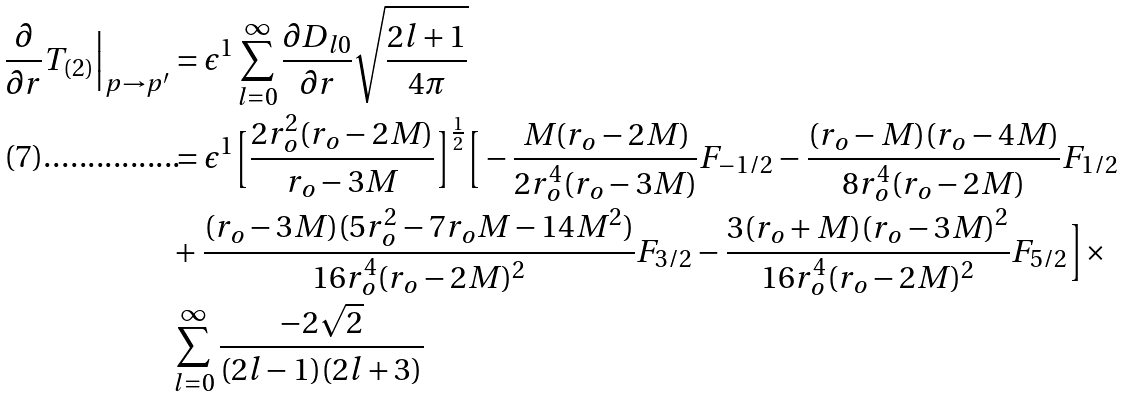Convert formula to latex. <formula><loc_0><loc_0><loc_500><loc_500>\frac { \partial } { \partial r } T _ { ( 2 ) } \Big | _ { p \to p ^ { \prime } } & = \epsilon ^ { 1 } \sum _ { l = 0 } ^ { \infty } \frac { \partial D _ { l 0 } } { \partial r } \sqrt { \frac { 2 l + 1 } { 4 \pi } } \\ & = \epsilon ^ { 1 } \Big [ \frac { 2 r _ { o } ^ { 2 } ( r _ { o } - 2 M ) } { r _ { o } - 3 M } \Big ] ^ { \frac { 1 } { 2 } } \Big [ - \frac { M ( r _ { o } - 2 M ) } { 2 r _ { o } ^ { 4 } ( r _ { o } - 3 M ) } F _ { - 1 / 2 } - \frac { ( r _ { o } - M ) ( r _ { o } - 4 M ) } { 8 r _ { o } ^ { 4 } ( r _ { o } - 2 M ) } F _ { 1 / 2 } \\ & + \frac { ( r _ { o } - 3 M ) ( 5 r _ { o } ^ { 2 } - 7 r _ { o } M - 1 4 M ^ { 2 } ) } { 1 6 r _ { o } ^ { 4 } ( r _ { o } - 2 M ) ^ { 2 } } F _ { 3 / 2 } - \frac { 3 ( r _ { o } + M ) ( r _ { o } - 3 M ) ^ { 2 } } { 1 6 r _ { o } ^ { 4 } ( r _ { o } - 2 M ) ^ { 2 } } F _ { 5 / 2 } \Big ] \times \\ & \sum _ { l = 0 } ^ { \infty } \frac { - 2 \sqrt { 2 } } { ( 2 l - 1 ) ( 2 l + 3 ) } \\</formula> 